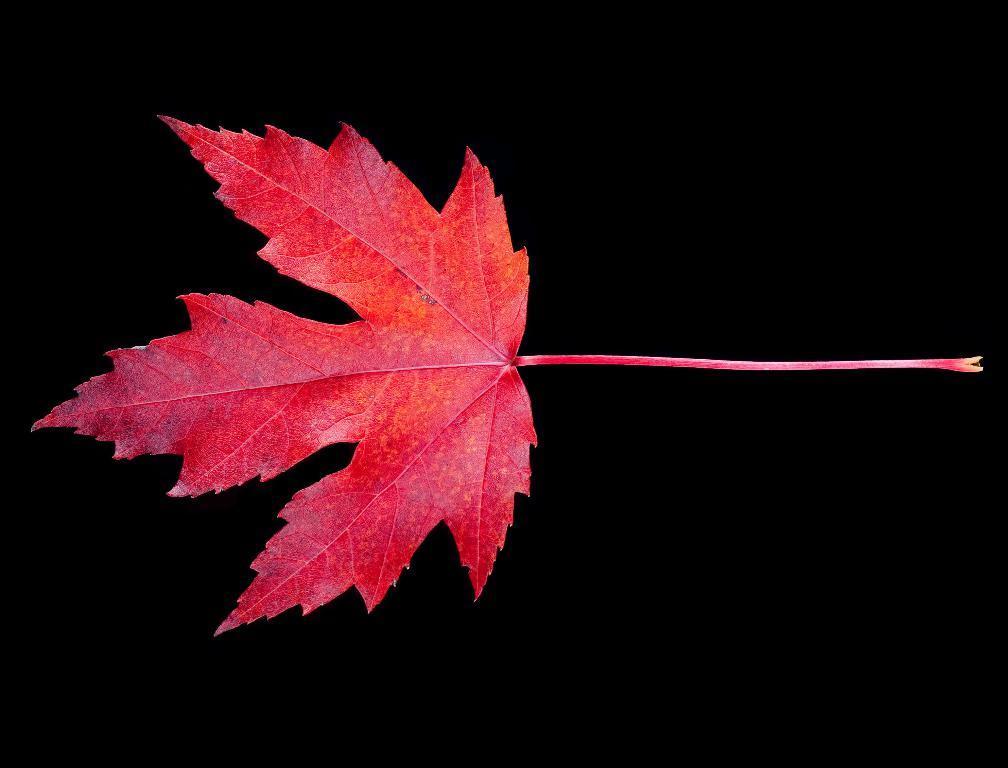Can you describe this image briefly? In this image there is a leaf. The background is dark. 